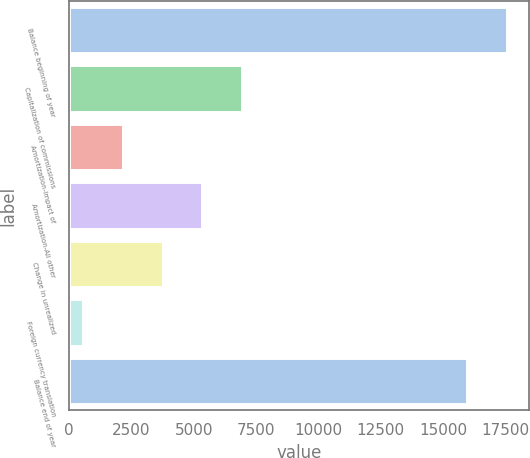Convert chart to OTSL. <chart><loc_0><loc_0><loc_500><loc_500><bar_chart><fcel>Balance beginning of year<fcel>Capitalization of commissions<fcel>Amortization-Impact of<fcel>Amortization-All other<fcel>Change in unrealized<fcel>Foreign currency translation<fcel>Balance end of year<nl><fcel>17565.7<fcel>6943.8<fcel>2159.7<fcel>5349.1<fcel>3754.4<fcel>565<fcel>15971<nl></chart> 